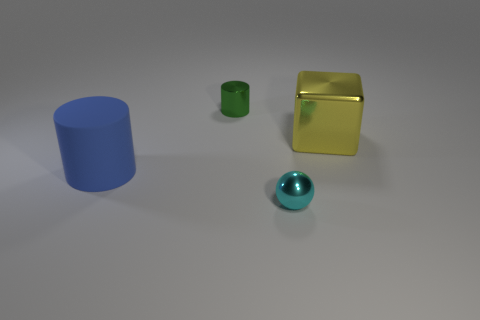Add 3 tiny cyan objects. How many objects exist? 7 Subtract all balls. How many objects are left? 3 Add 1 green objects. How many green objects exist? 2 Subtract 0 green spheres. How many objects are left? 4 Subtract all brown metallic balls. Subtract all big yellow metal things. How many objects are left? 3 Add 2 cyan balls. How many cyan balls are left? 3 